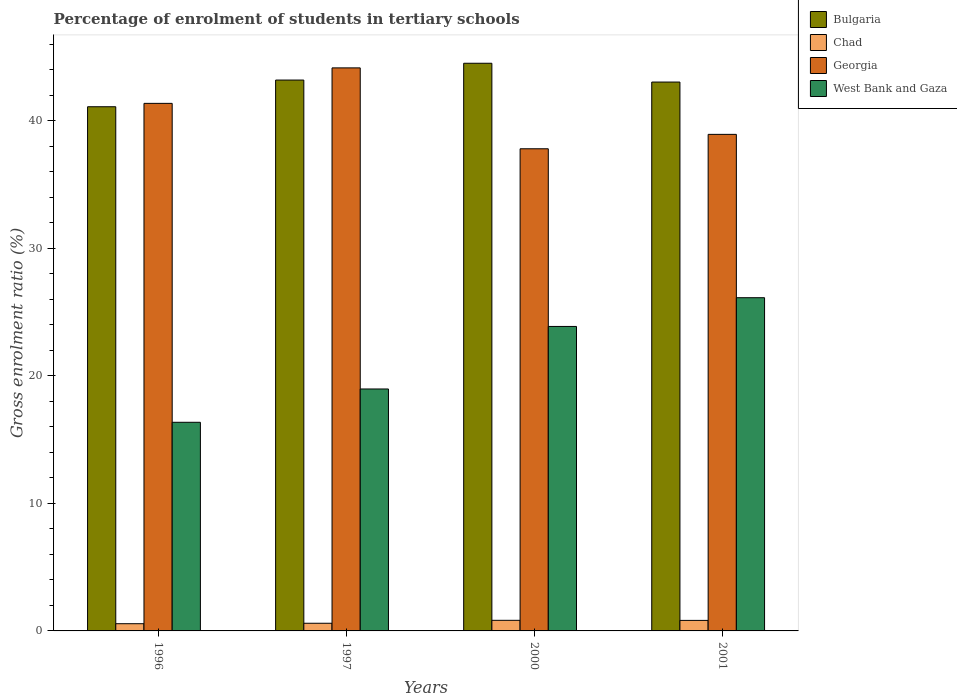Are the number of bars per tick equal to the number of legend labels?
Offer a very short reply. Yes. How many bars are there on the 4th tick from the right?
Give a very brief answer. 4. In how many cases, is the number of bars for a given year not equal to the number of legend labels?
Keep it short and to the point. 0. What is the percentage of students enrolled in tertiary schools in West Bank and Gaza in 2001?
Offer a terse response. 26.12. Across all years, what is the maximum percentage of students enrolled in tertiary schools in West Bank and Gaza?
Make the answer very short. 26.12. Across all years, what is the minimum percentage of students enrolled in tertiary schools in West Bank and Gaza?
Offer a terse response. 16.35. In which year was the percentage of students enrolled in tertiary schools in West Bank and Gaza maximum?
Offer a terse response. 2001. In which year was the percentage of students enrolled in tertiary schools in Bulgaria minimum?
Make the answer very short. 1996. What is the total percentage of students enrolled in tertiary schools in Georgia in the graph?
Provide a short and direct response. 162.18. What is the difference between the percentage of students enrolled in tertiary schools in Georgia in 1996 and that in 2000?
Offer a very short reply. 3.56. What is the difference between the percentage of students enrolled in tertiary schools in Bulgaria in 1997 and the percentage of students enrolled in tertiary schools in Chad in 2001?
Your answer should be compact. 42.35. What is the average percentage of students enrolled in tertiary schools in West Bank and Gaza per year?
Make the answer very short. 21.32. In the year 1997, what is the difference between the percentage of students enrolled in tertiary schools in West Bank and Gaza and percentage of students enrolled in tertiary schools in Georgia?
Provide a short and direct response. -25.17. What is the ratio of the percentage of students enrolled in tertiary schools in West Bank and Gaza in 1997 to that in 2000?
Offer a very short reply. 0.79. Is the difference between the percentage of students enrolled in tertiary schools in West Bank and Gaza in 1996 and 2000 greater than the difference between the percentage of students enrolled in tertiary schools in Georgia in 1996 and 2000?
Provide a succinct answer. No. What is the difference between the highest and the second highest percentage of students enrolled in tertiary schools in Georgia?
Ensure brevity in your answer.  2.78. What is the difference between the highest and the lowest percentage of students enrolled in tertiary schools in Bulgaria?
Ensure brevity in your answer.  3.41. What does the 4th bar from the left in 2000 represents?
Your answer should be compact. West Bank and Gaza. What does the 1st bar from the right in 1996 represents?
Give a very brief answer. West Bank and Gaza. Are all the bars in the graph horizontal?
Offer a very short reply. No. What is the difference between two consecutive major ticks on the Y-axis?
Offer a very short reply. 10. Are the values on the major ticks of Y-axis written in scientific E-notation?
Keep it short and to the point. No. Does the graph contain any zero values?
Provide a succinct answer. No. How many legend labels are there?
Provide a short and direct response. 4. How are the legend labels stacked?
Your answer should be very brief. Vertical. What is the title of the graph?
Your response must be concise. Percentage of enrolment of students in tertiary schools. What is the label or title of the X-axis?
Give a very brief answer. Years. What is the label or title of the Y-axis?
Keep it short and to the point. Gross enrolment ratio (%). What is the Gross enrolment ratio (%) of Bulgaria in 1996?
Your response must be concise. 41.08. What is the Gross enrolment ratio (%) in Chad in 1996?
Make the answer very short. 0.56. What is the Gross enrolment ratio (%) in Georgia in 1996?
Ensure brevity in your answer.  41.35. What is the Gross enrolment ratio (%) in West Bank and Gaza in 1996?
Make the answer very short. 16.35. What is the Gross enrolment ratio (%) in Bulgaria in 1997?
Provide a succinct answer. 43.17. What is the Gross enrolment ratio (%) of Chad in 1997?
Your response must be concise. 0.6. What is the Gross enrolment ratio (%) in Georgia in 1997?
Your answer should be compact. 44.13. What is the Gross enrolment ratio (%) of West Bank and Gaza in 1997?
Provide a short and direct response. 18.96. What is the Gross enrolment ratio (%) in Bulgaria in 2000?
Give a very brief answer. 44.49. What is the Gross enrolment ratio (%) of Chad in 2000?
Your response must be concise. 0.83. What is the Gross enrolment ratio (%) in Georgia in 2000?
Your answer should be compact. 37.79. What is the Gross enrolment ratio (%) in West Bank and Gaza in 2000?
Provide a short and direct response. 23.86. What is the Gross enrolment ratio (%) in Bulgaria in 2001?
Keep it short and to the point. 43.02. What is the Gross enrolment ratio (%) in Chad in 2001?
Provide a short and direct response. 0.83. What is the Gross enrolment ratio (%) of Georgia in 2001?
Offer a very short reply. 38.92. What is the Gross enrolment ratio (%) in West Bank and Gaza in 2001?
Give a very brief answer. 26.12. Across all years, what is the maximum Gross enrolment ratio (%) in Bulgaria?
Make the answer very short. 44.49. Across all years, what is the maximum Gross enrolment ratio (%) in Chad?
Provide a succinct answer. 0.83. Across all years, what is the maximum Gross enrolment ratio (%) in Georgia?
Your response must be concise. 44.13. Across all years, what is the maximum Gross enrolment ratio (%) of West Bank and Gaza?
Your answer should be very brief. 26.12. Across all years, what is the minimum Gross enrolment ratio (%) of Bulgaria?
Ensure brevity in your answer.  41.08. Across all years, what is the minimum Gross enrolment ratio (%) of Chad?
Offer a very short reply. 0.56. Across all years, what is the minimum Gross enrolment ratio (%) in Georgia?
Provide a succinct answer. 37.79. Across all years, what is the minimum Gross enrolment ratio (%) in West Bank and Gaza?
Offer a terse response. 16.35. What is the total Gross enrolment ratio (%) of Bulgaria in the graph?
Provide a short and direct response. 171.77. What is the total Gross enrolment ratio (%) in Chad in the graph?
Make the answer very short. 2.82. What is the total Gross enrolment ratio (%) of Georgia in the graph?
Provide a short and direct response. 162.18. What is the total Gross enrolment ratio (%) in West Bank and Gaza in the graph?
Make the answer very short. 85.29. What is the difference between the Gross enrolment ratio (%) of Bulgaria in 1996 and that in 1997?
Provide a succinct answer. -2.09. What is the difference between the Gross enrolment ratio (%) in Chad in 1996 and that in 1997?
Ensure brevity in your answer.  -0.04. What is the difference between the Gross enrolment ratio (%) of Georgia in 1996 and that in 1997?
Make the answer very short. -2.78. What is the difference between the Gross enrolment ratio (%) in West Bank and Gaza in 1996 and that in 1997?
Your response must be concise. -2.61. What is the difference between the Gross enrolment ratio (%) of Bulgaria in 1996 and that in 2000?
Provide a short and direct response. -3.41. What is the difference between the Gross enrolment ratio (%) in Chad in 1996 and that in 2000?
Your answer should be compact. -0.27. What is the difference between the Gross enrolment ratio (%) in Georgia in 1996 and that in 2000?
Your answer should be compact. 3.56. What is the difference between the Gross enrolment ratio (%) in West Bank and Gaza in 1996 and that in 2000?
Make the answer very short. -7.51. What is the difference between the Gross enrolment ratio (%) in Bulgaria in 1996 and that in 2001?
Your answer should be very brief. -1.93. What is the difference between the Gross enrolment ratio (%) in Chad in 1996 and that in 2001?
Make the answer very short. -0.26. What is the difference between the Gross enrolment ratio (%) of Georgia in 1996 and that in 2001?
Offer a very short reply. 2.43. What is the difference between the Gross enrolment ratio (%) in West Bank and Gaza in 1996 and that in 2001?
Provide a succinct answer. -9.76. What is the difference between the Gross enrolment ratio (%) of Bulgaria in 1997 and that in 2000?
Provide a succinct answer. -1.32. What is the difference between the Gross enrolment ratio (%) in Chad in 1997 and that in 2000?
Keep it short and to the point. -0.23. What is the difference between the Gross enrolment ratio (%) of Georgia in 1997 and that in 2000?
Make the answer very short. 6.34. What is the difference between the Gross enrolment ratio (%) of West Bank and Gaza in 1997 and that in 2000?
Your response must be concise. -4.9. What is the difference between the Gross enrolment ratio (%) of Bulgaria in 1997 and that in 2001?
Offer a very short reply. 0.16. What is the difference between the Gross enrolment ratio (%) of Chad in 1997 and that in 2001?
Offer a very short reply. -0.22. What is the difference between the Gross enrolment ratio (%) in Georgia in 1997 and that in 2001?
Your answer should be compact. 5.21. What is the difference between the Gross enrolment ratio (%) in West Bank and Gaza in 1997 and that in 2001?
Provide a short and direct response. -7.15. What is the difference between the Gross enrolment ratio (%) in Bulgaria in 2000 and that in 2001?
Ensure brevity in your answer.  1.47. What is the difference between the Gross enrolment ratio (%) of Chad in 2000 and that in 2001?
Offer a very short reply. 0.01. What is the difference between the Gross enrolment ratio (%) in Georgia in 2000 and that in 2001?
Offer a very short reply. -1.13. What is the difference between the Gross enrolment ratio (%) in West Bank and Gaza in 2000 and that in 2001?
Provide a succinct answer. -2.25. What is the difference between the Gross enrolment ratio (%) in Bulgaria in 1996 and the Gross enrolment ratio (%) in Chad in 1997?
Offer a terse response. 40.48. What is the difference between the Gross enrolment ratio (%) of Bulgaria in 1996 and the Gross enrolment ratio (%) of Georgia in 1997?
Give a very brief answer. -3.04. What is the difference between the Gross enrolment ratio (%) in Bulgaria in 1996 and the Gross enrolment ratio (%) in West Bank and Gaza in 1997?
Make the answer very short. 22.12. What is the difference between the Gross enrolment ratio (%) of Chad in 1996 and the Gross enrolment ratio (%) of Georgia in 1997?
Offer a terse response. -43.56. What is the difference between the Gross enrolment ratio (%) in Chad in 1996 and the Gross enrolment ratio (%) in West Bank and Gaza in 1997?
Keep it short and to the point. -18.4. What is the difference between the Gross enrolment ratio (%) in Georgia in 1996 and the Gross enrolment ratio (%) in West Bank and Gaza in 1997?
Your response must be concise. 22.39. What is the difference between the Gross enrolment ratio (%) in Bulgaria in 1996 and the Gross enrolment ratio (%) in Chad in 2000?
Make the answer very short. 40.25. What is the difference between the Gross enrolment ratio (%) in Bulgaria in 1996 and the Gross enrolment ratio (%) in Georgia in 2000?
Ensure brevity in your answer.  3.29. What is the difference between the Gross enrolment ratio (%) of Bulgaria in 1996 and the Gross enrolment ratio (%) of West Bank and Gaza in 2000?
Offer a terse response. 17.22. What is the difference between the Gross enrolment ratio (%) in Chad in 1996 and the Gross enrolment ratio (%) in Georgia in 2000?
Provide a succinct answer. -37.22. What is the difference between the Gross enrolment ratio (%) in Chad in 1996 and the Gross enrolment ratio (%) in West Bank and Gaza in 2000?
Provide a short and direct response. -23.3. What is the difference between the Gross enrolment ratio (%) in Georgia in 1996 and the Gross enrolment ratio (%) in West Bank and Gaza in 2000?
Ensure brevity in your answer.  17.48. What is the difference between the Gross enrolment ratio (%) in Bulgaria in 1996 and the Gross enrolment ratio (%) in Chad in 2001?
Provide a short and direct response. 40.26. What is the difference between the Gross enrolment ratio (%) in Bulgaria in 1996 and the Gross enrolment ratio (%) in Georgia in 2001?
Your answer should be very brief. 2.16. What is the difference between the Gross enrolment ratio (%) in Bulgaria in 1996 and the Gross enrolment ratio (%) in West Bank and Gaza in 2001?
Your response must be concise. 14.97. What is the difference between the Gross enrolment ratio (%) in Chad in 1996 and the Gross enrolment ratio (%) in Georgia in 2001?
Ensure brevity in your answer.  -38.35. What is the difference between the Gross enrolment ratio (%) of Chad in 1996 and the Gross enrolment ratio (%) of West Bank and Gaza in 2001?
Give a very brief answer. -25.55. What is the difference between the Gross enrolment ratio (%) of Georgia in 1996 and the Gross enrolment ratio (%) of West Bank and Gaza in 2001?
Your answer should be very brief. 15.23. What is the difference between the Gross enrolment ratio (%) of Bulgaria in 1997 and the Gross enrolment ratio (%) of Chad in 2000?
Provide a succinct answer. 42.34. What is the difference between the Gross enrolment ratio (%) in Bulgaria in 1997 and the Gross enrolment ratio (%) in Georgia in 2000?
Offer a terse response. 5.39. What is the difference between the Gross enrolment ratio (%) in Bulgaria in 1997 and the Gross enrolment ratio (%) in West Bank and Gaza in 2000?
Ensure brevity in your answer.  19.31. What is the difference between the Gross enrolment ratio (%) of Chad in 1997 and the Gross enrolment ratio (%) of Georgia in 2000?
Your answer should be compact. -37.19. What is the difference between the Gross enrolment ratio (%) of Chad in 1997 and the Gross enrolment ratio (%) of West Bank and Gaza in 2000?
Give a very brief answer. -23.26. What is the difference between the Gross enrolment ratio (%) of Georgia in 1997 and the Gross enrolment ratio (%) of West Bank and Gaza in 2000?
Your answer should be compact. 20.27. What is the difference between the Gross enrolment ratio (%) in Bulgaria in 1997 and the Gross enrolment ratio (%) in Chad in 2001?
Your answer should be compact. 42.35. What is the difference between the Gross enrolment ratio (%) of Bulgaria in 1997 and the Gross enrolment ratio (%) of Georgia in 2001?
Ensure brevity in your answer.  4.26. What is the difference between the Gross enrolment ratio (%) of Bulgaria in 1997 and the Gross enrolment ratio (%) of West Bank and Gaza in 2001?
Provide a short and direct response. 17.06. What is the difference between the Gross enrolment ratio (%) in Chad in 1997 and the Gross enrolment ratio (%) in Georgia in 2001?
Ensure brevity in your answer.  -38.32. What is the difference between the Gross enrolment ratio (%) in Chad in 1997 and the Gross enrolment ratio (%) in West Bank and Gaza in 2001?
Provide a short and direct response. -25.52. What is the difference between the Gross enrolment ratio (%) of Georgia in 1997 and the Gross enrolment ratio (%) of West Bank and Gaza in 2001?
Ensure brevity in your answer.  18.01. What is the difference between the Gross enrolment ratio (%) in Bulgaria in 2000 and the Gross enrolment ratio (%) in Chad in 2001?
Ensure brevity in your answer.  43.67. What is the difference between the Gross enrolment ratio (%) of Bulgaria in 2000 and the Gross enrolment ratio (%) of Georgia in 2001?
Keep it short and to the point. 5.57. What is the difference between the Gross enrolment ratio (%) in Bulgaria in 2000 and the Gross enrolment ratio (%) in West Bank and Gaza in 2001?
Make the answer very short. 18.38. What is the difference between the Gross enrolment ratio (%) in Chad in 2000 and the Gross enrolment ratio (%) in Georgia in 2001?
Provide a succinct answer. -38.09. What is the difference between the Gross enrolment ratio (%) in Chad in 2000 and the Gross enrolment ratio (%) in West Bank and Gaza in 2001?
Provide a succinct answer. -25.29. What is the difference between the Gross enrolment ratio (%) of Georgia in 2000 and the Gross enrolment ratio (%) of West Bank and Gaza in 2001?
Give a very brief answer. 11.67. What is the average Gross enrolment ratio (%) in Bulgaria per year?
Ensure brevity in your answer.  42.94. What is the average Gross enrolment ratio (%) of Chad per year?
Offer a very short reply. 0.71. What is the average Gross enrolment ratio (%) in Georgia per year?
Make the answer very short. 40.55. What is the average Gross enrolment ratio (%) in West Bank and Gaza per year?
Offer a terse response. 21.32. In the year 1996, what is the difference between the Gross enrolment ratio (%) of Bulgaria and Gross enrolment ratio (%) of Chad?
Provide a short and direct response. 40.52. In the year 1996, what is the difference between the Gross enrolment ratio (%) of Bulgaria and Gross enrolment ratio (%) of Georgia?
Your response must be concise. -0.26. In the year 1996, what is the difference between the Gross enrolment ratio (%) in Bulgaria and Gross enrolment ratio (%) in West Bank and Gaza?
Your answer should be compact. 24.73. In the year 1996, what is the difference between the Gross enrolment ratio (%) of Chad and Gross enrolment ratio (%) of Georgia?
Offer a very short reply. -40.78. In the year 1996, what is the difference between the Gross enrolment ratio (%) in Chad and Gross enrolment ratio (%) in West Bank and Gaza?
Make the answer very short. -15.79. In the year 1996, what is the difference between the Gross enrolment ratio (%) in Georgia and Gross enrolment ratio (%) in West Bank and Gaza?
Keep it short and to the point. 25. In the year 1997, what is the difference between the Gross enrolment ratio (%) in Bulgaria and Gross enrolment ratio (%) in Chad?
Provide a succinct answer. 42.57. In the year 1997, what is the difference between the Gross enrolment ratio (%) of Bulgaria and Gross enrolment ratio (%) of Georgia?
Your answer should be very brief. -0.95. In the year 1997, what is the difference between the Gross enrolment ratio (%) of Bulgaria and Gross enrolment ratio (%) of West Bank and Gaza?
Your answer should be very brief. 24.21. In the year 1997, what is the difference between the Gross enrolment ratio (%) in Chad and Gross enrolment ratio (%) in Georgia?
Ensure brevity in your answer.  -43.53. In the year 1997, what is the difference between the Gross enrolment ratio (%) in Chad and Gross enrolment ratio (%) in West Bank and Gaza?
Ensure brevity in your answer.  -18.36. In the year 1997, what is the difference between the Gross enrolment ratio (%) in Georgia and Gross enrolment ratio (%) in West Bank and Gaza?
Give a very brief answer. 25.17. In the year 2000, what is the difference between the Gross enrolment ratio (%) of Bulgaria and Gross enrolment ratio (%) of Chad?
Your response must be concise. 43.66. In the year 2000, what is the difference between the Gross enrolment ratio (%) of Bulgaria and Gross enrolment ratio (%) of Georgia?
Your answer should be compact. 6.7. In the year 2000, what is the difference between the Gross enrolment ratio (%) in Bulgaria and Gross enrolment ratio (%) in West Bank and Gaza?
Provide a short and direct response. 20.63. In the year 2000, what is the difference between the Gross enrolment ratio (%) in Chad and Gross enrolment ratio (%) in Georgia?
Your answer should be compact. -36.96. In the year 2000, what is the difference between the Gross enrolment ratio (%) of Chad and Gross enrolment ratio (%) of West Bank and Gaza?
Provide a succinct answer. -23.03. In the year 2000, what is the difference between the Gross enrolment ratio (%) of Georgia and Gross enrolment ratio (%) of West Bank and Gaza?
Make the answer very short. 13.93. In the year 2001, what is the difference between the Gross enrolment ratio (%) in Bulgaria and Gross enrolment ratio (%) in Chad?
Your answer should be very brief. 42.19. In the year 2001, what is the difference between the Gross enrolment ratio (%) in Bulgaria and Gross enrolment ratio (%) in Georgia?
Make the answer very short. 4.1. In the year 2001, what is the difference between the Gross enrolment ratio (%) in Bulgaria and Gross enrolment ratio (%) in West Bank and Gaza?
Make the answer very short. 16.9. In the year 2001, what is the difference between the Gross enrolment ratio (%) of Chad and Gross enrolment ratio (%) of Georgia?
Give a very brief answer. -38.09. In the year 2001, what is the difference between the Gross enrolment ratio (%) in Chad and Gross enrolment ratio (%) in West Bank and Gaza?
Give a very brief answer. -25.29. In the year 2001, what is the difference between the Gross enrolment ratio (%) in Georgia and Gross enrolment ratio (%) in West Bank and Gaza?
Your answer should be compact. 12.8. What is the ratio of the Gross enrolment ratio (%) in Bulgaria in 1996 to that in 1997?
Provide a succinct answer. 0.95. What is the ratio of the Gross enrolment ratio (%) of Chad in 1996 to that in 1997?
Keep it short and to the point. 0.94. What is the ratio of the Gross enrolment ratio (%) of Georgia in 1996 to that in 1997?
Offer a very short reply. 0.94. What is the ratio of the Gross enrolment ratio (%) of West Bank and Gaza in 1996 to that in 1997?
Make the answer very short. 0.86. What is the ratio of the Gross enrolment ratio (%) of Bulgaria in 1996 to that in 2000?
Make the answer very short. 0.92. What is the ratio of the Gross enrolment ratio (%) of Chad in 1996 to that in 2000?
Offer a terse response. 0.68. What is the ratio of the Gross enrolment ratio (%) in Georgia in 1996 to that in 2000?
Provide a succinct answer. 1.09. What is the ratio of the Gross enrolment ratio (%) in West Bank and Gaza in 1996 to that in 2000?
Give a very brief answer. 0.69. What is the ratio of the Gross enrolment ratio (%) in Bulgaria in 1996 to that in 2001?
Your response must be concise. 0.95. What is the ratio of the Gross enrolment ratio (%) of Chad in 1996 to that in 2001?
Keep it short and to the point. 0.68. What is the ratio of the Gross enrolment ratio (%) of Georgia in 1996 to that in 2001?
Your answer should be compact. 1.06. What is the ratio of the Gross enrolment ratio (%) in West Bank and Gaza in 1996 to that in 2001?
Ensure brevity in your answer.  0.63. What is the ratio of the Gross enrolment ratio (%) of Bulgaria in 1997 to that in 2000?
Give a very brief answer. 0.97. What is the ratio of the Gross enrolment ratio (%) in Chad in 1997 to that in 2000?
Offer a terse response. 0.72. What is the ratio of the Gross enrolment ratio (%) of Georgia in 1997 to that in 2000?
Your answer should be very brief. 1.17. What is the ratio of the Gross enrolment ratio (%) of West Bank and Gaza in 1997 to that in 2000?
Your answer should be very brief. 0.79. What is the ratio of the Gross enrolment ratio (%) in Bulgaria in 1997 to that in 2001?
Keep it short and to the point. 1. What is the ratio of the Gross enrolment ratio (%) in Chad in 1997 to that in 2001?
Offer a terse response. 0.73. What is the ratio of the Gross enrolment ratio (%) in Georgia in 1997 to that in 2001?
Make the answer very short. 1.13. What is the ratio of the Gross enrolment ratio (%) in West Bank and Gaza in 1997 to that in 2001?
Provide a succinct answer. 0.73. What is the ratio of the Gross enrolment ratio (%) of Bulgaria in 2000 to that in 2001?
Ensure brevity in your answer.  1.03. What is the ratio of the Gross enrolment ratio (%) of Chad in 2000 to that in 2001?
Your answer should be compact. 1.01. What is the ratio of the Gross enrolment ratio (%) of West Bank and Gaza in 2000 to that in 2001?
Provide a succinct answer. 0.91. What is the difference between the highest and the second highest Gross enrolment ratio (%) of Bulgaria?
Ensure brevity in your answer.  1.32. What is the difference between the highest and the second highest Gross enrolment ratio (%) of Chad?
Provide a short and direct response. 0.01. What is the difference between the highest and the second highest Gross enrolment ratio (%) of Georgia?
Make the answer very short. 2.78. What is the difference between the highest and the second highest Gross enrolment ratio (%) of West Bank and Gaza?
Give a very brief answer. 2.25. What is the difference between the highest and the lowest Gross enrolment ratio (%) of Bulgaria?
Ensure brevity in your answer.  3.41. What is the difference between the highest and the lowest Gross enrolment ratio (%) in Chad?
Your answer should be compact. 0.27. What is the difference between the highest and the lowest Gross enrolment ratio (%) of Georgia?
Ensure brevity in your answer.  6.34. What is the difference between the highest and the lowest Gross enrolment ratio (%) in West Bank and Gaza?
Provide a short and direct response. 9.76. 